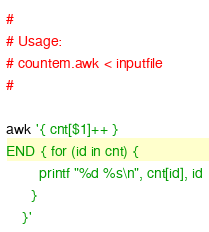Convert code to text. <code><loc_0><loc_0><loc_500><loc_500><_Awk_>#
# Usage:
# countem.awk < inputfile
#

awk '{ cnt[$1]++ }
END { for (id in cnt) {
        printf "%d %s\n", cnt[id], id
      }
    }'
</code> 